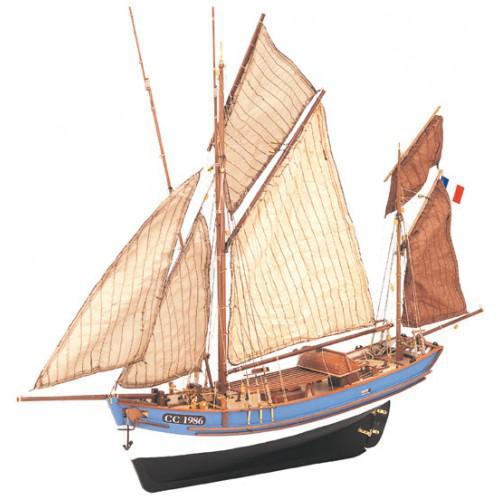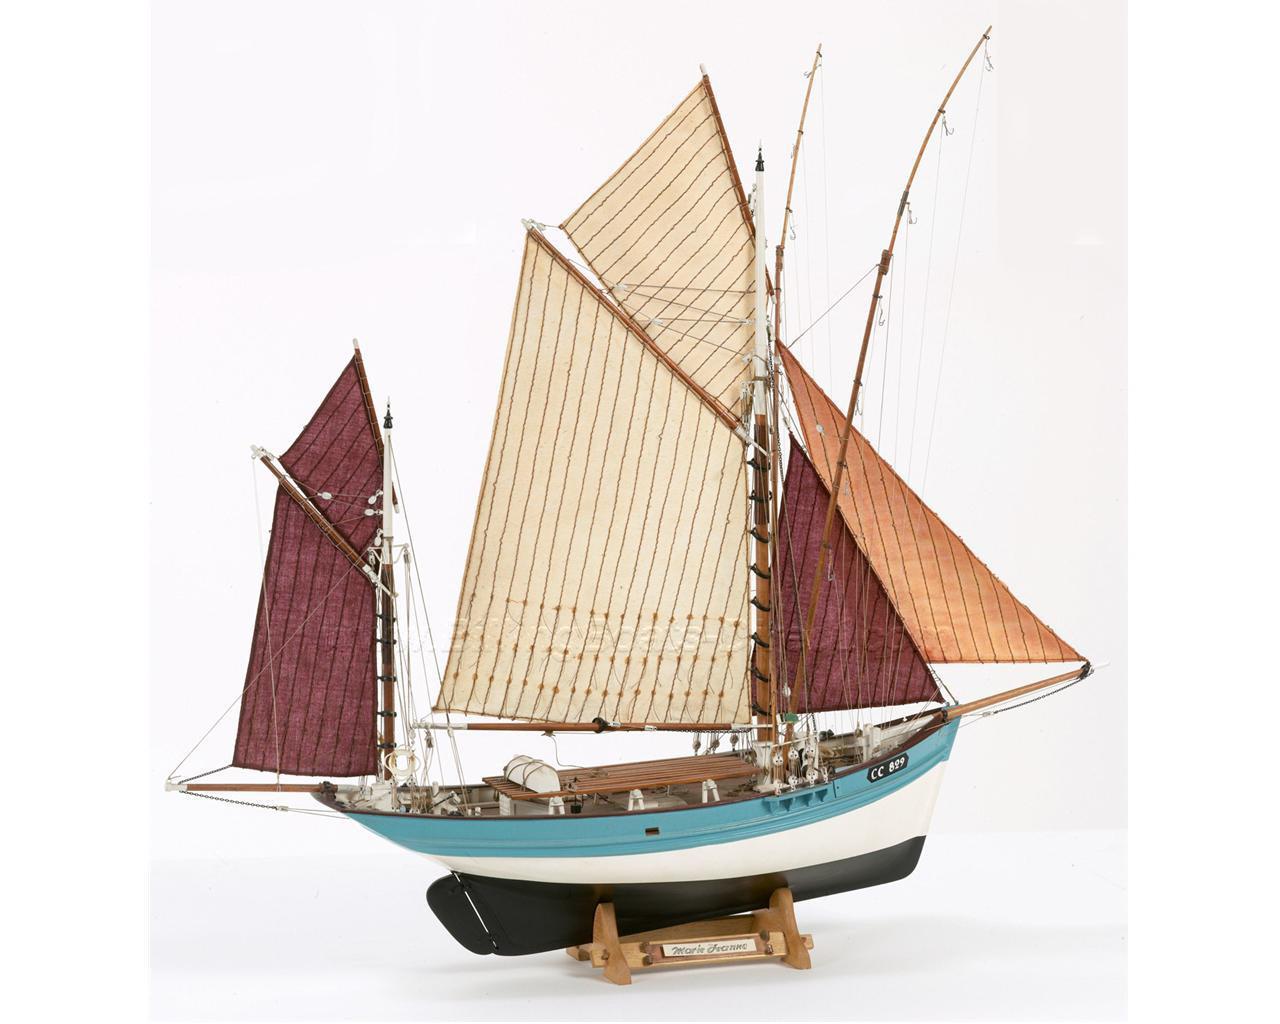The first image is the image on the left, the second image is the image on the right. Given the left and right images, does the statement "The boat in one of the images has exactly 6 sails" hold true? Answer yes or no. Yes. 